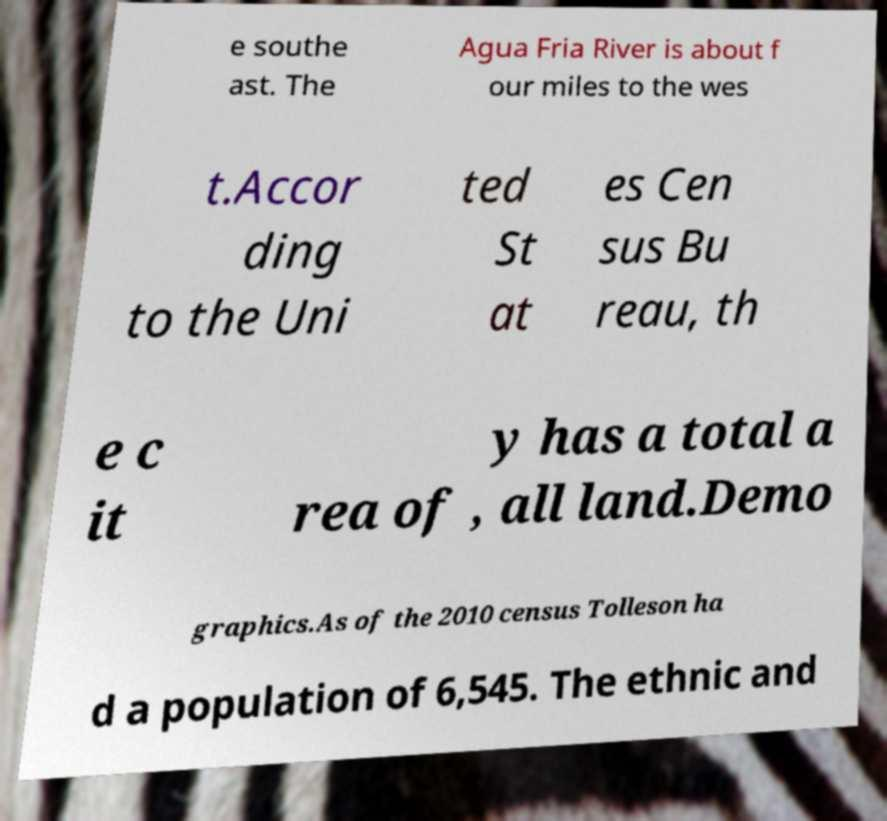I need the written content from this picture converted into text. Can you do that? e southe ast. The Agua Fria River is about f our miles to the wes t.Accor ding to the Uni ted St at es Cen sus Bu reau, th e c it y has a total a rea of , all land.Demo graphics.As of the 2010 census Tolleson ha d a population of 6,545. The ethnic and 